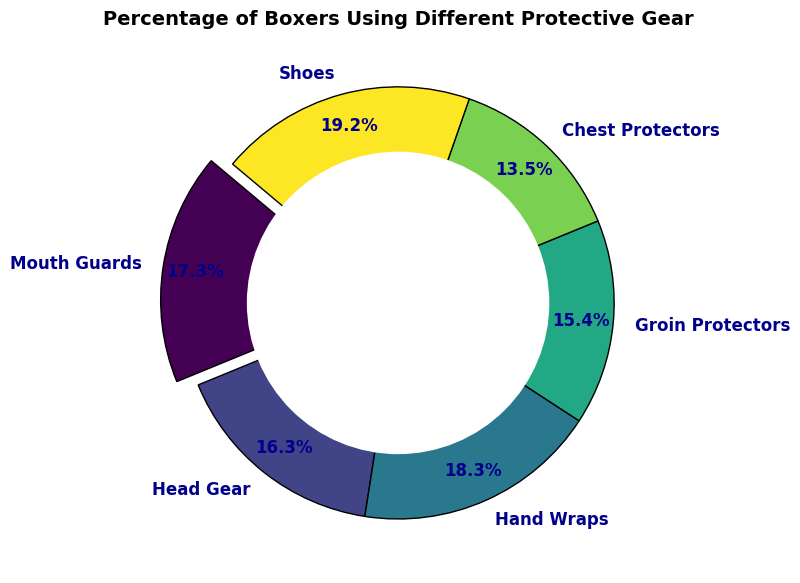What's the percentage of boxers using mouth guards? The percentage of boxers using mouth guards is directly shown in the ring chart as a segment representing 90%.
Answer: 90% Which protective gear is used by the highest percentage of boxers? By looking at the ring chart, the segment with the highest percentage is for shoes, which is labeled as 100%.
Answer: Shoes How much higher is the percentage of boxers using hand wraps compared to those using chest protectors? The percentage of boxers using hand wraps is 95%, and those using chest protectors is 70%. Subtracting these values gives 95% - 70% = 25%.
Answer: 25% What is the total percentage of boxers using both head gear and groin protectors? The percentage of boxers using head gear is 85%, and those using groin protectors is 80%. Adding these values gives 85% + 80% = 165%.
Answer: 165% For which gear is the segment highlighted or exploded in the ring chart? The ring chart highlights or explodes the segment for mouth guards.
Answer: Mouth guards Which protective gear has the smallest usage percentage and what is that percentage? By examining the ring chart, the segment with the smallest percentage is for chest protectors, which is labeled as 70%.
Answer: Chest protectors, 70% Compare the percentage use of mouth guards and head gear. Which one is more popular and by how much? The percentage of boxers using mouth guards is 90%, and those using head gear is 85%. Mouth guards are more popular by 90% - 85% = 5%.
Answer: Mouth guards by 5% What percentage of boxers use some form of hand or arm protection (hand wraps)? The ring chart shows that the percentage of boxers using hand wraps is 95%.
Answer: 95% Is the percentage of boxers using shoes higher than those using groin protectors? The percentage of boxers using shoes is 100%, and those using groin protectors is 80%. Since 100% is greater than 80%, yes, the percentage using shoes is higher.
Answer: Yes 